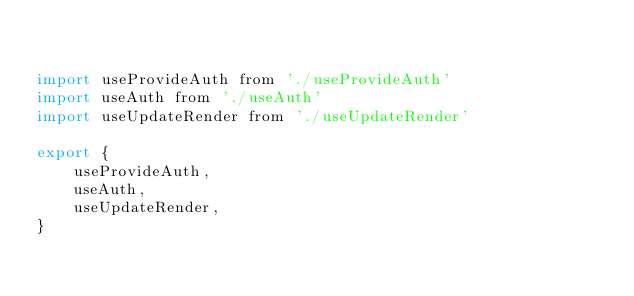Convert code to text. <code><loc_0><loc_0><loc_500><loc_500><_JavaScript_>

import useProvideAuth from './useProvideAuth'
import useAuth from './useAuth'
import useUpdateRender from './useUpdateRender'

export {
    useProvideAuth,
    useAuth,
    useUpdateRender,
}</code> 